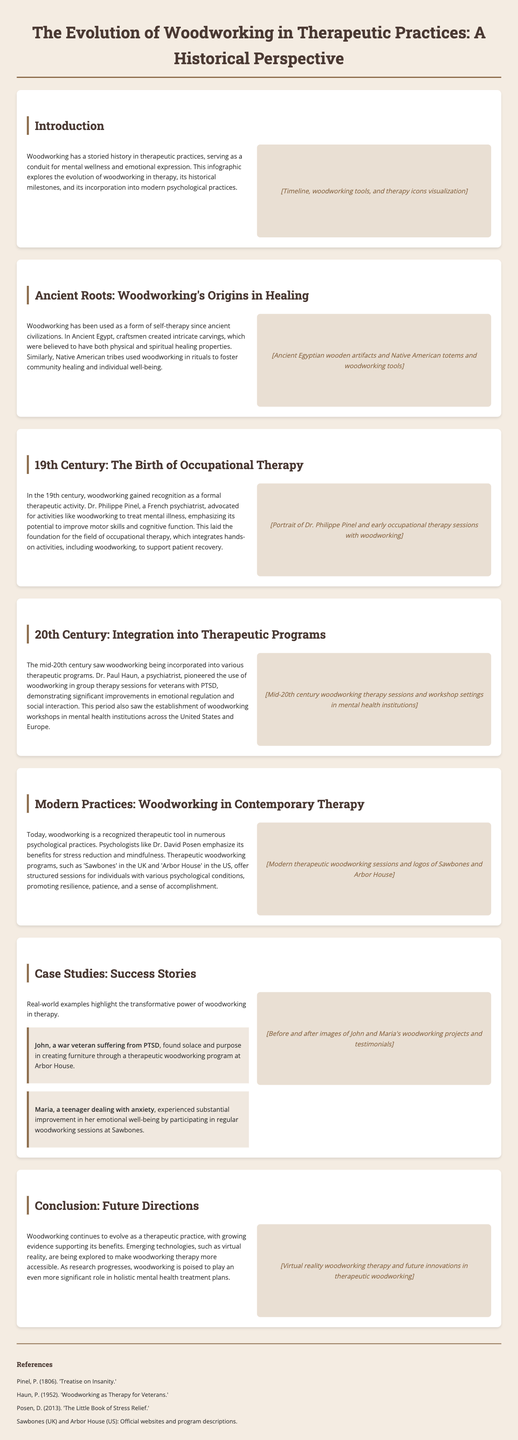What is the primary focus of the infographic? The infographic primarily focuses on the evolution and historical perspective of woodworking in therapeutic practices.
Answer: Evolution of woodworking in therapeutic practices Who advocated for woodworking as a therapeutic activity in the 19th century? Dr. Philippe Pinel is mentioned as the advocate for activities like woodworking to treat mental illness in the 19th century.
Answer: Dr. Philippe Pinel What did Dr. Paul Haun pioneer in the mid-20th century? Dr. Paul Haun pioneered the use of woodworking in group therapy sessions for veterans with PTSD.
Answer: Use of woodworking in group therapy Which two therapeutic woodworking programs are mentioned in modern practices? 'Sawbones' in the UK and 'Arbor House' in the US are highlighted as therapeutic woodworking programs.
Answer: Sawbones and Arbor House What materials were used by ancient Egyptians for healing? Ancient Egyptians created intricate carvings from wood, believed to have healing properties.
Answer: Intricate carvings What key benefit does woodworking provide according to modern psychologists? Modern psychologists, like Dr. David Posen, emphasize stress reduction as a key benefit of woodworking.
Answer: Stress reduction What was significant about woodworking during the 19th century? The 19th century marked the recognition of woodworking as a formal therapeutic activity.
Answer: Recognition as a formal therapeutic activity What type of content is found in the References section? The References section lists various sources that discuss the historical and therapeutic significance of woodworking.
Answer: Various sources on woodworking How does the infographic suggest woodworking therapy may evolve in the future? The infographic suggests that emerging technologies, like virtual reality, may make woodworking therapy more accessible in the future.
Answer: Virtual reality therapy 